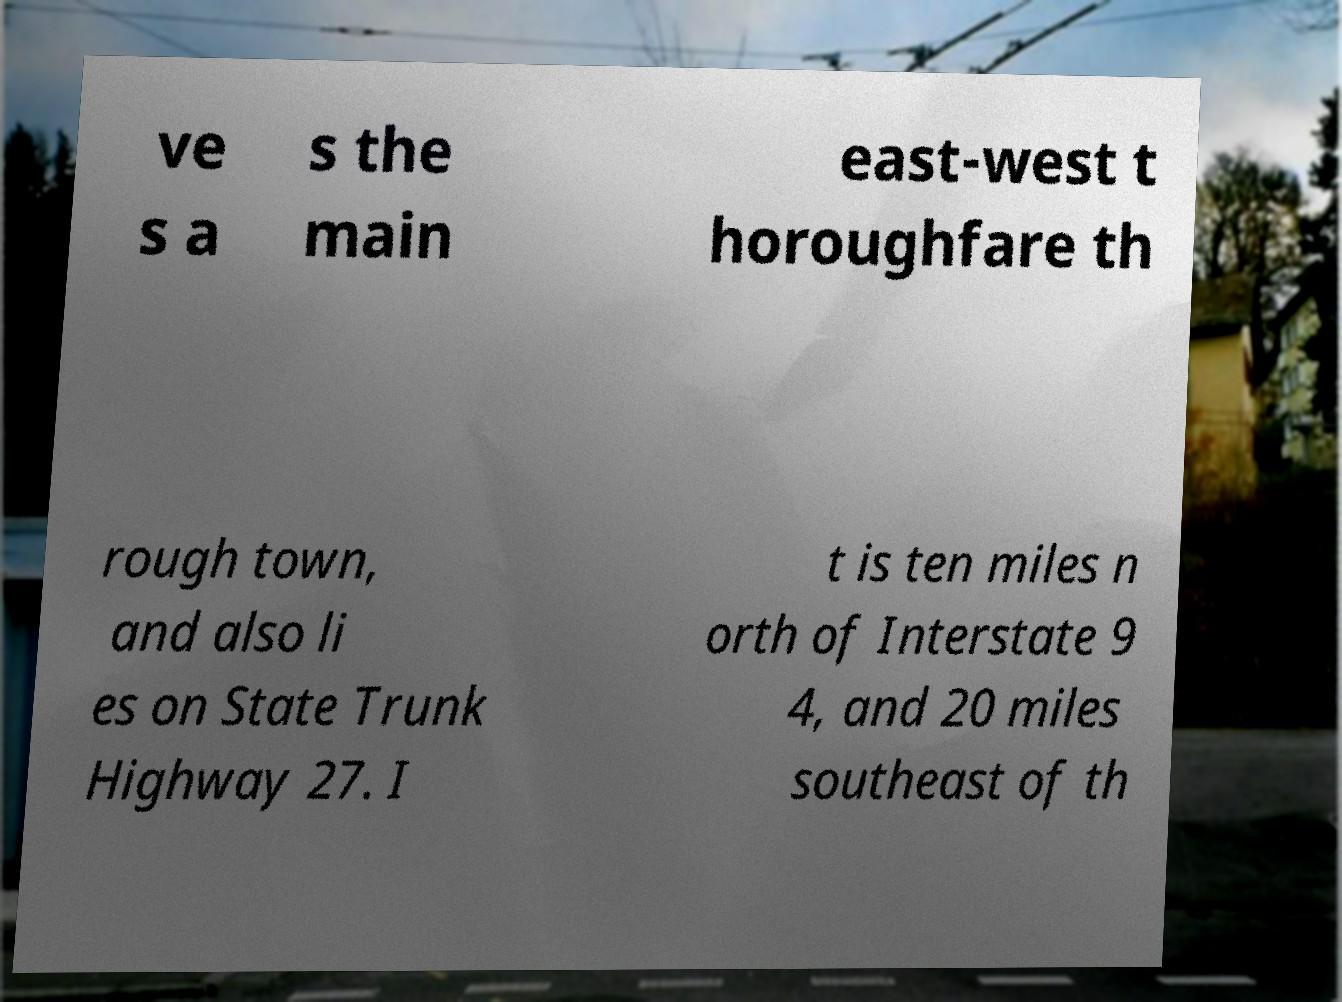Please read and relay the text visible in this image. What does it say? ve s a s the main east-west t horoughfare th rough town, and also li es on State Trunk Highway 27. I t is ten miles n orth of Interstate 9 4, and 20 miles southeast of th 